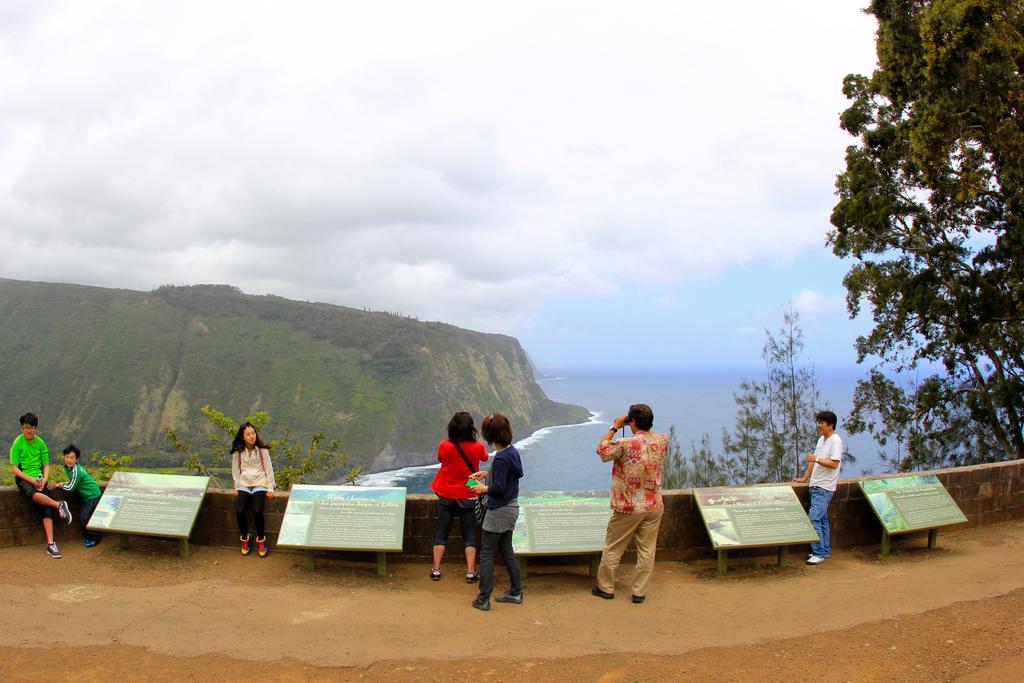In one or two sentences, can you explain what this image depicts? In this image there are clouds in the sky, there is a mountain truncated towards the left of the image, there is tree truncated towards the right of the image, there are persons, there are boards with text. 